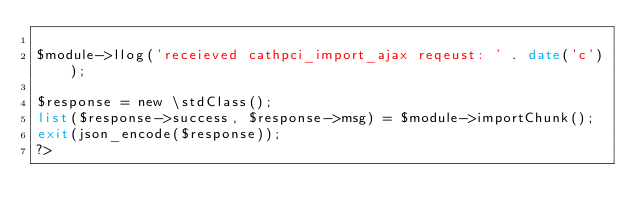Convert code to text. <code><loc_0><loc_0><loc_500><loc_500><_PHP_>
$module->llog('receieved cathpci_import_ajax reqeust: ' . date('c'));

$response = new \stdClass();
list($response->success, $response->msg) = $module->importChunk();
exit(json_encode($response));
?></code> 